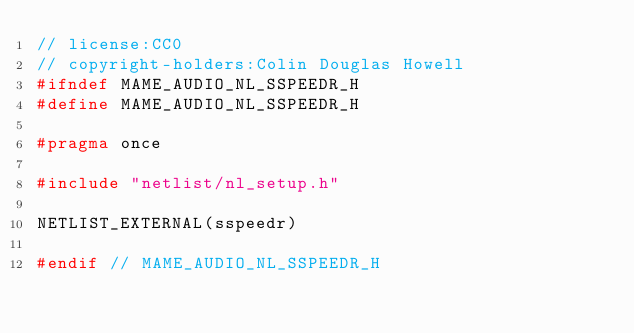Convert code to text. <code><loc_0><loc_0><loc_500><loc_500><_C_>// license:CC0
// copyright-holders:Colin Douglas Howell
#ifndef MAME_AUDIO_NL_SSPEEDR_H
#define MAME_AUDIO_NL_SSPEEDR_H

#pragma once

#include "netlist/nl_setup.h"

NETLIST_EXTERNAL(sspeedr)

#endif // MAME_AUDIO_NL_SSPEEDR_H
</code> 